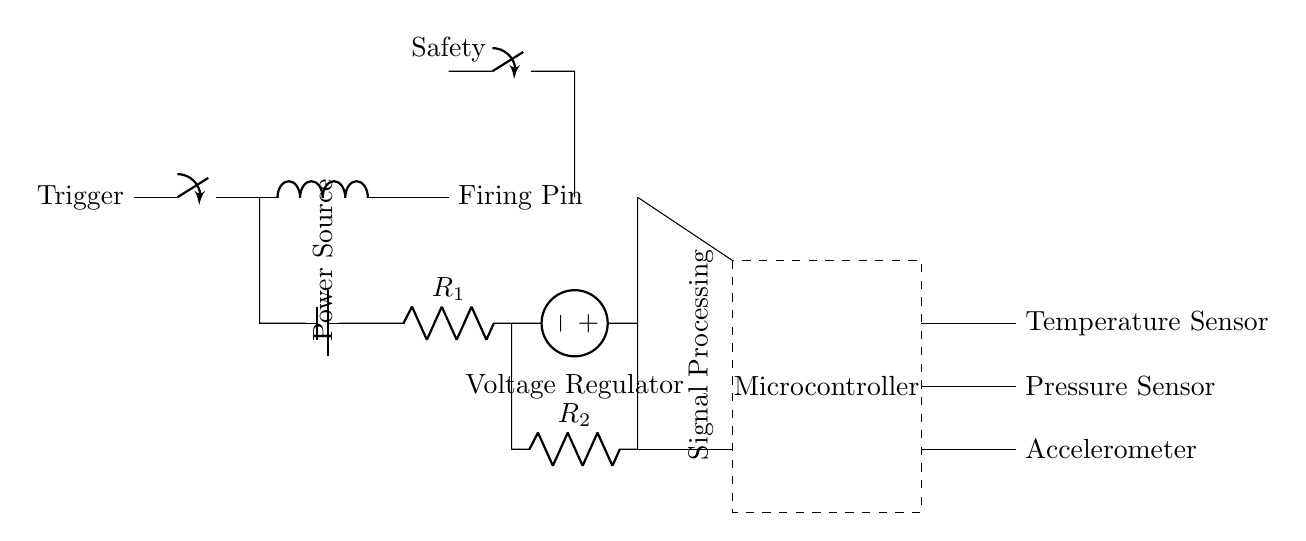What component is responsible for initiating the firing mechanism? The trigger is the component that initiates the firing mechanism by closing the switch, allowing electrical current to flow through the circuit.
Answer: Trigger What is the function of the microcontroller in this circuit? The microcontroller processes the signals from the sensors and controls the timing and operation of the firing mechanism through programming, making it central to the integration of electronic components.
Answer: Signal Processing How many resistors are present in the circuit diagram? There are two resistors in the circuit, labeled as R1 and R2, which regulate voltage and current paths.
Answer: Two What safety feature is included in this circuit? The circuit includes a safety switch that prevents accidental firing by ensuring the circuit remains open unless intentionally activated.
Answer: Safety switch What types of sensors are integrated into the system? The system integrates three types of sensors: a temperature sensor, a pressure sensor, and an accelerometer, which gather environmental and operational data for safe firing.
Answer: Temperature, Pressure, Accelerometer What is the source of power for this circuit? The power source for this circuit is a battery, which provides the necessary voltage for operation when the circuit is closed.
Answer: Battery Which component connects the mechanical and electronic parts of the circuit? The firing pin serves as the link between the mechanical aspect of the circuit (the trigger) and the electronic systems that control firing, enabling the actual discharge of the projectile.
Answer: Firing Pin 